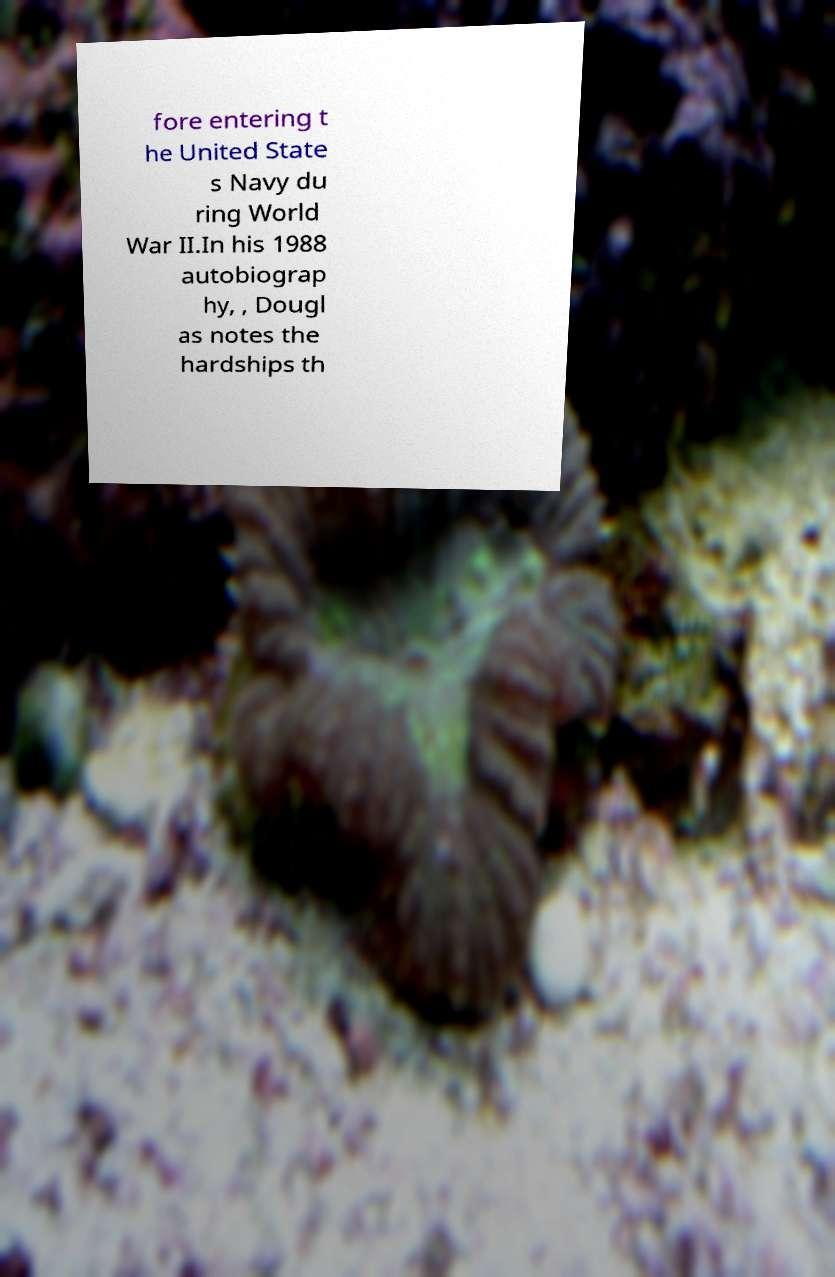For documentation purposes, I need the text within this image transcribed. Could you provide that? fore entering t he United State s Navy du ring World War II.In his 1988 autobiograp hy, , Dougl as notes the hardships th 